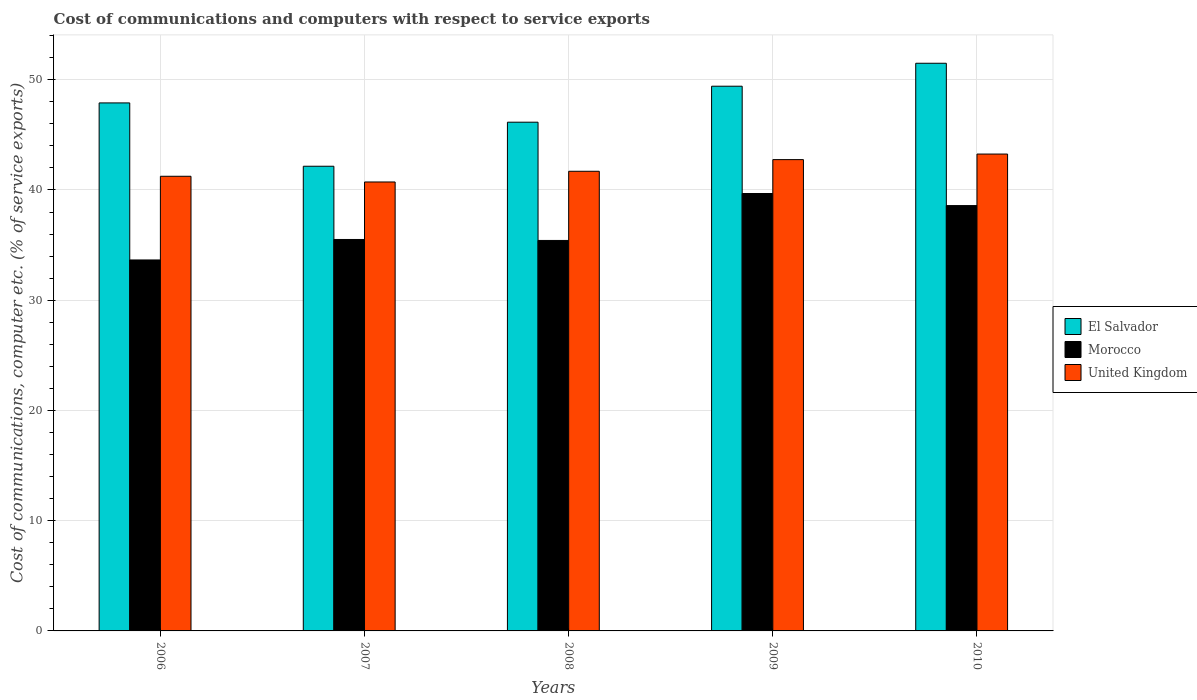How many different coloured bars are there?
Keep it short and to the point. 3. How many groups of bars are there?
Give a very brief answer. 5. Are the number of bars per tick equal to the number of legend labels?
Offer a very short reply. Yes. How many bars are there on the 4th tick from the left?
Keep it short and to the point. 3. What is the label of the 5th group of bars from the left?
Make the answer very short. 2010. In how many cases, is the number of bars for a given year not equal to the number of legend labels?
Make the answer very short. 0. What is the cost of communications and computers in United Kingdom in 2008?
Your answer should be compact. 41.69. Across all years, what is the maximum cost of communications and computers in United Kingdom?
Your answer should be compact. 43.26. Across all years, what is the minimum cost of communications and computers in El Salvador?
Ensure brevity in your answer.  42.15. In which year was the cost of communications and computers in El Salvador maximum?
Your answer should be very brief. 2010. What is the total cost of communications and computers in Morocco in the graph?
Offer a very short reply. 182.84. What is the difference between the cost of communications and computers in Morocco in 2006 and that in 2010?
Keep it short and to the point. -4.93. What is the difference between the cost of communications and computers in El Salvador in 2010 and the cost of communications and computers in United Kingdom in 2006?
Your answer should be very brief. 10.25. What is the average cost of communications and computers in El Salvador per year?
Keep it short and to the point. 47.42. In the year 2008, what is the difference between the cost of communications and computers in El Salvador and cost of communications and computers in United Kingdom?
Your response must be concise. 4.45. What is the ratio of the cost of communications and computers in El Salvador in 2007 to that in 2008?
Offer a very short reply. 0.91. Is the cost of communications and computers in El Salvador in 2008 less than that in 2009?
Keep it short and to the point. Yes. What is the difference between the highest and the second highest cost of communications and computers in El Salvador?
Provide a succinct answer. 2.08. What is the difference between the highest and the lowest cost of communications and computers in El Salvador?
Offer a terse response. 9.34. In how many years, is the cost of communications and computers in United Kingdom greater than the average cost of communications and computers in United Kingdom taken over all years?
Offer a very short reply. 2. Is the sum of the cost of communications and computers in United Kingdom in 2007 and 2010 greater than the maximum cost of communications and computers in El Salvador across all years?
Offer a very short reply. Yes. What does the 3rd bar from the right in 2010 represents?
Keep it short and to the point. El Salvador. Is it the case that in every year, the sum of the cost of communications and computers in El Salvador and cost of communications and computers in Morocco is greater than the cost of communications and computers in United Kingdom?
Your response must be concise. Yes. Are all the bars in the graph horizontal?
Give a very brief answer. No. Are the values on the major ticks of Y-axis written in scientific E-notation?
Make the answer very short. No. Where does the legend appear in the graph?
Provide a succinct answer. Center right. How many legend labels are there?
Your answer should be very brief. 3. What is the title of the graph?
Make the answer very short. Cost of communications and computers with respect to service exports. What is the label or title of the X-axis?
Offer a terse response. Years. What is the label or title of the Y-axis?
Provide a succinct answer. Cost of communications, computer etc. (% of service exports). What is the Cost of communications, computer etc. (% of service exports) of El Salvador in 2006?
Provide a succinct answer. 47.89. What is the Cost of communications, computer etc. (% of service exports) in Morocco in 2006?
Ensure brevity in your answer.  33.65. What is the Cost of communications, computer etc. (% of service exports) of United Kingdom in 2006?
Your answer should be compact. 41.24. What is the Cost of communications, computer etc. (% of service exports) of El Salvador in 2007?
Your answer should be compact. 42.15. What is the Cost of communications, computer etc. (% of service exports) in Morocco in 2007?
Your response must be concise. 35.51. What is the Cost of communications, computer etc. (% of service exports) in United Kingdom in 2007?
Keep it short and to the point. 40.72. What is the Cost of communications, computer etc. (% of service exports) in El Salvador in 2008?
Provide a short and direct response. 46.15. What is the Cost of communications, computer etc. (% of service exports) of Morocco in 2008?
Offer a terse response. 35.42. What is the Cost of communications, computer etc. (% of service exports) of United Kingdom in 2008?
Your response must be concise. 41.69. What is the Cost of communications, computer etc. (% of service exports) of El Salvador in 2009?
Your answer should be compact. 49.41. What is the Cost of communications, computer etc. (% of service exports) of Morocco in 2009?
Offer a terse response. 39.68. What is the Cost of communications, computer etc. (% of service exports) of United Kingdom in 2009?
Give a very brief answer. 42.75. What is the Cost of communications, computer etc. (% of service exports) of El Salvador in 2010?
Offer a terse response. 51.49. What is the Cost of communications, computer etc. (% of service exports) of Morocco in 2010?
Your answer should be compact. 38.58. What is the Cost of communications, computer etc. (% of service exports) of United Kingdom in 2010?
Provide a short and direct response. 43.26. Across all years, what is the maximum Cost of communications, computer etc. (% of service exports) in El Salvador?
Keep it short and to the point. 51.49. Across all years, what is the maximum Cost of communications, computer etc. (% of service exports) in Morocco?
Provide a short and direct response. 39.68. Across all years, what is the maximum Cost of communications, computer etc. (% of service exports) in United Kingdom?
Offer a very short reply. 43.26. Across all years, what is the minimum Cost of communications, computer etc. (% of service exports) of El Salvador?
Your response must be concise. 42.15. Across all years, what is the minimum Cost of communications, computer etc. (% of service exports) in Morocco?
Your response must be concise. 33.65. Across all years, what is the minimum Cost of communications, computer etc. (% of service exports) of United Kingdom?
Offer a terse response. 40.72. What is the total Cost of communications, computer etc. (% of service exports) of El Salvador in the graph?
Offer a terse response. 237.1. What is the total Cost of communications, computer etc. (% of service exports) in Morocco in the graph?
Provide a succinct answer. 182.84. What is the total Cost of communications, computer etc. (% of service exports) of United Kingdom in the graph?
Offer a terse response. 209.67. What is the difference between the Cost of communications, computer etc. (% of service exports) in El Salvador in 2006 and that in 2007?
Your response must be concise. 5.74. What is the difference between the Cost of communications, computer etc. (% of service exports) of Morocco in 2006 and that in 2007?
Provide a short and direct response. -1.86. What is the difference between the Cost of communications, computer etc. (% of service exports) of United Kingdom in 2006 and that in 2007?
Keep it short and to the point. 0.52. What is the difference between the Cost of communications, computer etc. (% of service exports) in El Salvador in 2006 and that in 2008?
Keep it short and to the point. 1.75. What is the difference between the Cost of communications, computer etc. (% of service exports) in Morocco in 2006 and that in 2008?
Ensure brevity in your answer.  -1.77. What is the difference between the Cost of communications, computer etc. (% of service exports) in United Kingdom in 2006 and that in 2008?
Keep it short and to the point. -0.45. What is the difference between the Cost of communications, computer etc. (% of service exports) of El Salvador in 2006 and that in 2009?
Keep it short and to the point. -1.52. What is the difference between the Cost of communications, computer etc. (% of service exports) in Morocco in 2006 and that in 2009?
Your response must be concise. -6.03. What is the difference between the Cost of communications, computer etc. (% of service exports) in United Kingdom in 2006 and that in 2009?
Provide a short and direct response. -1.51. What is the difference between the Cost of communications, computer etc. (% of service exports) in El Salvador in 2006 and that in 2010?
Your answer should be compact. -3.6. What is the difference between the Cost of communications, computer etc. (% of service exports) in Morocco in 2006 and that in 2010?
Your response must be concise. -4.93. What is the difference between the Cost of communications, computer etc. (% of service exports) in United Kingdom in 2006 and that in 2010?
Provide a succinct answer. -2.02. What is the difference between the Cost of communications, computer etc. (% of service exports) of El Salvador in 2007 and that in 2008?
Your answer should be very brief. -4. What is the difference between the Cost of communications, computer etc. (% of service exports) of Morocco in 2007 and that in 2008?
Provide a short and direct response. 0.09. What is the difference between the Cost of communications, computer etc. (% of service exports) in United Kingdom in 2007 and that in 2008?
Your response must be concise. -0.97. What is the difference between the Cost of communications, computer etc. (% of service exports) of El Salvador in 2007 and that in 2009?
Your answer should be very brief. -7.26. What is the difference between the Cost of communications, computer etc. (% of service exports) in Morocco in 2007 and that in 2009?
Your response must be concise. -4.17. What is the difference between the Cost of communications, computer etc. (% of service exports) of United Kingdom in 2007 and that in 2009?
Make the answer very short. -2.03. What is the difference between the Cost of communications, computer etc. (% of service exports) in El Salvador in 2007 and that in 2010?
Offer a very short reply. -9.34. What is the difference between the Cost of communications, computer etc. (% of service exports) in Morocco in 2007 and that in 2010?
Your response must be concise. -3.07. What is the difference between the Cost of communications, computer etc. (% of service exports) of United Kingdom in 2007 and that in 2010?
Your response must be concise. -2.53. What is the difference between the Cost of communications, computer etc. (% of service exports) of El Salvador in 2008 and that in 2009?
Provide a short and direct response. -3.26. What is the difference between the Cost of communications, computer etc. (% of service exports) in Morocco in 2008 and that in 2009?
Your answer should be compact. -4.26. What is the difference between the Cost of communications, computer etc. (% of service exports) of United Kingdom in 2008 and that in 2009?
Provide a short and direct response. -1.06. What is the difference between the Cost of communications, computer etc. (% of service exports) in El Salvador in 2008 and that in 2010?
Your response must be concise. -5.35. What is the difference between the Cost of communications, computer etc. (% of service exports) in Morocco in 2008 and that in 2010?
Your response must be concise. -3.16. What is the difference between the Cost of communications, computer etc. (% of service exports) of United Kingdom in 2008 and that in 2010?
Keep it short and to the point. -1.56. What is the difference between the Cost of communications, computer etc. (% of service exports) of El Salvador in 2009 and that in 2010?
Your answer should be compact. -2.08. What is the difference between the Cost of communications, computer etc. (% of service exports) in Morocco in 2009 and that in 2010?
Keep it short and to the point. 1.1. What is the difference between the Cost of communications, computer etc. (% of service exports) of United Kingdom in 2009 and that in 2010?
Your response must be concise. -0.51. What is the difference between the Cost of communications, computer etc. (% of service exports) in El Salvador in 2006 and the Cost of communications, computer etc. (% of service exports) in Morocco in 2007?
Offer a very short reply. 12.39. What is the difference between the Cost of communications, computer etc. (% of service exports) of El Salvador in 2006 and the Cost of communications, computer etc. (% of service exports) of United Kingdom in 2007?
Offer a terse response. 7.17. What is the difference between the Cost of communications, computer etc. (% of service exports) of Morocco in 2006 and the Cost of communications, computer etc. (% of service exports) of United Kingdom in 2007?
Keep it short and to the point. -7.07. What is the difference between the Cost of communications, computer etc. (% of service exports) of El Salvador in 2006 and the Cost of communications, computer etc. (% of service exports) of Morocco in 2008?
Make the answer very short. 12.47. What is the difference between the Cost of communications, computer etc. (% of service exports) of El Salvador in 2006 and the Cost of communications, computer etc. (% of service exports) of United Kingdom in 2008?
Your response must be concise. 6.2. What is the difference between the Cost of communications, computer etc. (% of service exports) in Morocco in 2006 and the Cost of communications, computer etc. (% of service exports) in United Kingdom in 2008?
Provide a succinct answer. -8.05. What is the difference between the Cost of communications, computer etc. (% of service exports) in El Salvador in 2006 and the Cost of communications, computer etc. (% of service exports) in Morocco in 2009?
Offer a terse response. 8.22. What is the difference between the Cost of communications, computer etc. (% of service exports) in El Salvador in 2006 and the Cost of communications, computer etc. (% of service exports) in United Kingdom in 2009?
Your answer should be very brief. 5.14. What is the difference between the Cost of communications, computer etc. (% of service exports) of Morocco in 2006 and the Cost of communications, computer etc. (% of service exports) of United Kingdom in 2009?
Provide a short and direct response. -9.1. What is the difference between the Cost of communications, computer etc. (% of service exports) in El Salvador in 2006 and the Cost of communications, computer etc. (% of service exports) in Morocco in 2010?
Provide a succinct answer. 9.31. What is the difference between the Cost of communications, computer etc. (% of service exports) in El Salvador in 2006 and the Cost of communications, computer etc. (% of service exports) in United Kingdom in 2010?
Give a very brief answer. 4.64. What is the difference between the Cost of communications, computer etc. (% of service exports) in Morocco in 2006 and the Cost of communications, computer etc. (% of service exports) in United Kingdom in 2010?
Provide a short and direct response. -9.61. What is the difference between the Cost of communications, computer etc. (% of service exports) in El Salvador in 2007 and the Cost of communications, computer etc. (% of service exports) in Morocco in 2008?
Make the answer very short. 6.73. What is the difference between the Cost of communications, computer etc. (% of service exports) of El Salvador in 2007 and the Cost of communications, computer etc. (% of service exports) of United Kingdom in 2008?
Make the answer very short. 0.46. What is the difference between the Cost of communications, computer etc. (% of service exports) in Morocco in 2007 and the Cost of communications, computer etc. (% of service exports) in United Kingdom in 2008?
Provide a succinct answer. -6.19. What is the difference between the Cost of communications, computer etc. (% of service exports) in El Salvador in 2007 and the Cost of communications, computer etc. (% of service exports) in Morocco in 2009?
Keep it short and to the point. 2.47. What is the difference between the Cost of communications, computer etc. (% of service exports) in El Salvador in 2007 and the Cost of communications, computer etc. (% of service exports) in United Kingdom in 2009?
Provide a short and direct response. -0.6. What is the difference between the Cost of communications, computer etc. (% of service exports) in Morocco in 2007 and the Cost of communications, computer etc. (% of service exports) in United Kingdom in 2009?
Your response must be concise. -7.24. What is the difference between the Cost of communications, computer etc. (% of service exports) of El Salvador in 2007 and the Cost of communications, computer etc. (% of service exports) of Morocco in 2010?
Ensure brevity in your answer.  3.57. What is the difference between the Cost of communications, computer etc. (% of service exports) in El Salvador in 2007 and the Cost of communications, computer etc. (% of service exports) in United Kingdom in 2010?
Ensure brevity in your answer.  -1.11. What is the difference between the Cost of communications, computer etc. (% of service exports) of Morocco in 2007 and the Cost of communications, computer etc. (% of service exports) of United Kingdom in 2010?
Your response must be concise. -7.75. What is the difference between the Cost of communications, computer etc. (% of service exports) in El Salvador in 2008 and the Cost of communications, computer etc. (% of service exports) in Morocco in 2009?
Provide a succinct answer. 6.47. What is the difference between the Cost of communications, computer etc. (% of service exports) of El Salvador in 2008 and the Cost of communications, computer etc. (% of service exports) of United Kingdom in 2009?
Your answer should be compact. 3.4. What is the difference between the Cost of communications, computer etc. (% of service exports) of Morocco in 2008 and the Cost of communications, computer etc. (% of service exports) of United Kingdom in 2009?
Your answer should be compact. -7.33. What is the difference between the Cost of communications, computer etc. (% of service exports) in El Salvador in 2008 and the Cost of communications, computer etc. (% of service exports) in Morocco in 2010?
Your answer should be compact. 7.57. What is the difference between the Cost of communications, computer etc. (% of service exports) of El Salvador in 2008 and the Cost of communications, computer etc. (% of service exports) of United Kingdom in 2010?
Offer a very short reply. 2.89. What is the difference between the Cost of communications, computer etc. (% of service exports) in Morocco in 2008 and the Cost of communications, computer etc. (% of service exports) in United Kingdom in 2010?
Provide a short and direct response. -7.84. What is the difference between the Cost of communications, computer etc. (% of service exports) of El Salvador in 2009 and the Cost of communications, computer etc. (% of service exports) of Morocco in 2010?
Your response must be concise. 10.83. What is the difference between the Cost of communications, computer etc. (% of service exports) of El Salvador in 2009 and the Cost of communications, computer etc. (% of service exports) of United Kingdom in 2010?
Make the answer very short. 6.15. What is the difference between the Cost of communications, computer etc. (% of service exports) in Morocco in 2009 and the Cost of communications, computer etc. (% of service exports) in United Kingdom in 2010?
Your answer should be very brief. -3.58. What is the average Cost of communications, computer etc. (% of service exports) of El Salvador per year?
Ensure brevity in your answer.  47.42. What is the average Cost of communications, computer etc. (% of service exports) in Morocco per year?
Offer a terse response. 36.57. What is the average Cost of communications, computer etc. (% of service exports) in United Kingdom per year?
Give a very brief answer. 41.93. In the year 2006, what is the difference between the Cost of communications, computer etc. (% of service exports) of El Salvador and Cost of communications, computer etc. (% of service exports) of Morocco?
Ensure brevity in your answer.  14.24. In the year 2006, what is the difference between the Cost of communications, computer etc. (% of service exports) of El Salvador and Cost of communications, computer etc. (% of service exports) of United Kingdom?
Provide a short and direct response. 6.65. In the year 2006, what is the difference between the Cost of communications, computer etc. (% of service exports) in Morocco and Cost of communications, computer etc. (% of service exports) in United Kingdom?
Keep it short and to the point. -7.59. In the year 2007, what is the difference between the Cost of communications, computer etc. (% of service exports) of El Salvador and Cost of communications, computer etc. (% of service exports) of Morocco?
Your answer should be compact. 6.64. In the year 2007, what is the difference between the Cost of communications, computer etc. (% of service exports) in El Salvador and Cost of communications, computer etc. (% of service exports) in United Kingdom?
Provide a short and direct response. 1.43. In the year 2007, what is the difference between the Cost of communications, computer etc. (% of service exports) in Morocco and Cost of communications, computer etc. (% of service exports) in United Kingdom?
Keep it short and to the point. -5.22. In the year 2008, what is the difference between the Cost of communications, computer etc. (% of service exports) in El Salvador and Cost of communications, computer etc. (% of service exports) in Morocco?
Give a very brief answer. 10.73. In the year 2008, what is the difference between the Cost of communications, computer etc. (% of service exports) of El Salvador and Cost of communications, computer etc. (% of service exports) of United Kingdom?
Offer a very short reply. 4.45. In the year 2008, what is the difference between the Cost of communications, computer etc. (% of service exports) of Morocco and Cost of communications, computer etc. (% of service exports) of United Kingdom?
Your response must be concise. -6.27. In the year 2009, what is the difference between the Cost of communications, computer etc. (% of service exports) in El Salvador and Cost of communications, computer etc. (% of service exports) in Morocco?
Your answer should be compact. 9.73. In the year 2009, what is the difference between the Cost of communications, computer etc. (% of service exports) in El Salvador and Cost of communications, computer etc. (% of service exports) in United Kingdom?
Your response must be concise. 6.66. In the year 2009, what is the difference between the Cost of communications, computer etc. (% of service exports) in Morocco and Cost of communications, computer etc. (% of service exports) in United Kingdom?
Keep it short and to the point. -3.07. In the year 2010, what is the difference between the Cost of communications, computer etc. (% of service exports) of El Salvador and Cost of communications, computer etc. (% of service exports) of Morocco?
Give a very brief answer. 12.91. In the year 2010, what is the difference between the Cost of communications, computer etc. (% of service exports) in El Salvador and Cost of communications, computer etc. (% of service exports) in United Kingdom?
Your answer should be compact. 8.24. In the year 2010, what is the difference between the Cost of communications, computer etc. (% of service exports) in Morocco and Cost of communications, computer etc. (% of service exports) in United Kingdom?
Your response must be concise. -4.68. What is the ratio of the Cost of communications, computer etc. (% of service exports) of El Salvador in 2006 to that in 2007?
Provide a succinct answer. 1.14. What is the ratio of the Cost of communications, computer etc. (% of service exports) in Morocco in 2006 to that in 2007?
Offer a terse response. 0.95. What is the ratio of the Cost of communications, computer etc. (% of service exports) of United Kingdom in 2006 to that in 2007?
Give a very brief answer. 1.01. What is the ratio of the Cost of communications, computer etc. (% of service exports) in El Salvador in 2006 to that in 2008?
Make the answer very short. 1.04. What is the ratio of the Cost of communications, computer etc. (% of service exports) in United Kingdom in 2006 to that in 2008?
Keep it short and to the point. 0.99. What is the ratio of the Cost of communications, computer etc. (% of service exports) of El Salvador in 2006 to that in 2009?
Make the answer very short. 0.97. What is the ratio of the Cost of communications, computer etc. (% of service exports) in Morocco in 2006 to that in 2009?
Provide a succinct answer. 0.85. What is the ratio of the Cost of communications, computer etc. (% of service exports) of United Kingdom in 2006 to that in 2009?
Your answer should be very brief. 0.96. What is the ratio of the Cost of communications, computer etc. (% of service exports) of El Salvador in 2006 to that in 2010?
Provide a short and direct response. 0.93. What is the ratio of the Cost of communications, computer etc. (% of service exports) in Morocco in 2006 to that in 2010?
Keep it short and to the point. 0.87. What is the ratio of the Cost of communications, computer etc. (% of service exports) of United Kingdom in 2006 to that in 2010?
Give a very brief answer. 0.95. What is the ratio of the Cost of communications, computer etc. (% of service exports) in El Salvador in 2007 to that in 2008?
Make the answer very short. 0.91. What is the ratio of the Cost of communications, computer etc. (% of service exports) of Morocco in 2007 to that in 2008?
Your response must be concise. 1. What is the ratio of the Cost of communications, computer etc. (% of service exports) in United Kingdom in 2007 to that in 2008?
Make the answer very short. 0.98. What is the ratio of the Cost of communications, computer etc. (% of service exports) of El Salvador in 2007 to that in 2009?
Your answer should be very brief. 0.85. What is the ratio of the Cost of communications, computer etc. (% of service exports) in Morocco in 2007 to that in 2009?
Offer a very short reply. 0.89. What is the ratio of the Cost of communications, computer etc. (% of service exports) in United Kingdom in 2007 to that in 2009?
Offer a terse response. 0.95. What is the ratio of the Cost of communications, computer etc. (% of service exports) of El Salvador in 2007 to that in 2010?
Keep it short and to the point. 0.82. What is the ratio of the Cost of communications, computer etc. (% of service exports) in Morocco in 2007 to that in 2010?
Give a very brief answer. 0.92. What is the ratio of the Cost of communications, computer etc. (% of service exports) of United Kingdom in 2007 to that in 2010?
Your response must be concise. 0.94. What is the ratio of the Cost of communications, computer etc. (% of service exports) in El Salvador in 2008 to that in 2009?
Give a very brief answer. 0.93. What is the ratio of the Cost of communications, computer etc. (% of service exports) in Morocco in 2008 to that in 2009?
Give a very brief answer. 0.89. What is the ratio of the Cost of communications, computer etc. (% of service exports) in United Kingdom in 2008 to that in 2009?
Make the answer very short. 0.98. What is the ratio of the Cost of communications, computer etc. (% of service exports) in El Salvador in 2008 to that in 2010?
Make the answer very short. 0.9. What is the ratio of the Cost of communications, computer etc. (% of service exports) in Morocco in 2008 to that in 2010?
Offer a very short reply. 0.92. What is the ratio of the Cost of communications, computer etc. (% of service exports) in United Kingdom in 2008 to that in 2010?
Offer a terse response. 0.96. What is the ratio of the Cost of communications, computer etc. (% of service exports) of El Salvador in 2009 to that in 2010?
Provide a short and direct response. 0.96. What is the ratio of the Cost of communications, computer etc. (% of service exports) of Morocco in 2009 to that in 2010?
Offer a terse response. 1.03. What is the ratio of the Cost of communications, computer etc. (% of service exports) of United Kingdom in 2009 to that in 2010?
Provide a succinct answer. 0.99. What is the difference between the highest and the second highest Cost of communications, computer etc. (% of service exports) in El Salvador?
Provide a succinct answer. 2.08. What is the difference between the highest and the second highest Cost of communications, computer etc. (% of service exports) of Morocco?
Provide a succinct answer. 1.1. What is the difference between the highest and the second highest Cost of communications, computer etc. (% of service exports) of United Kingdom?
Provide a succinct answer. 0.51. What is the difference between the highest and the lowest Cost of communications, computer etc. (% of service exports) of El Salvador?
Give a very brief answer. 9.34. What is the difference between the highest and the lowest Cost of communications, computer etc. (% of service exports) of Morocco?
Provide a short and direct response. 6.03. What is the difference between the highest and the lowest Cost of communications, computer etc. (% of service exports) of United Kingdom?
Offer a terse response. 2.53. 